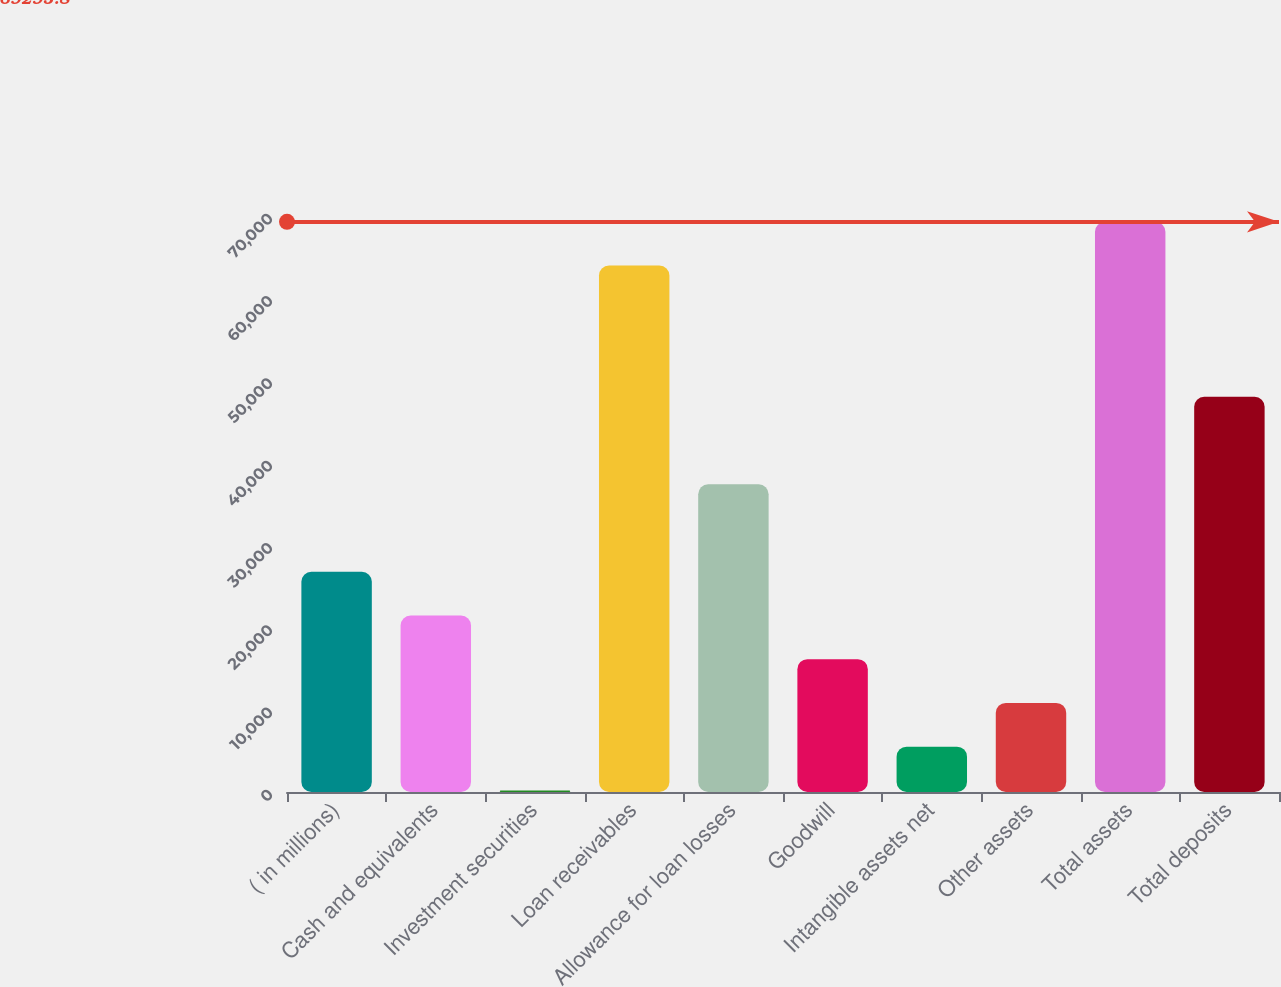Convert chart. <chart><loc_0><loc_0><loc_500><loc_500><bar_chart><fcel>( in millions)<fcel>Cash and equivalents<fcel>Investment securities<fcel>Loan receivables<fcel>Allowance for loan losses<fcel>Goodwill<fcel>Intangible assets net<fcel>Other assets<fcel>Total assets<fcel>Total deposits<nl><fcel>26771<fcel>21455.4<fcel>193<fcel>63980.2<fcel>37402.2<fcel>16139.8<fcel>5508.6<fcel>10824.2<fcel>69295.8<fcel>48033.4<nl></chart> 